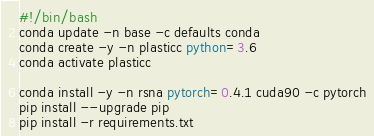Convert code to text. <code><loc_0><loc_0><loc_500><loc_500><_Bash_>#!/bin/bash
conda update -n base -c defaults conda
conda create -y -n plasticc python=3.6
conda activate plasticc

conda install -y -n rsna pytorch=0.4.1 cuda90 -c pytorch
pip install --upgrade pip
pip install -r requirements.txt


</code> 